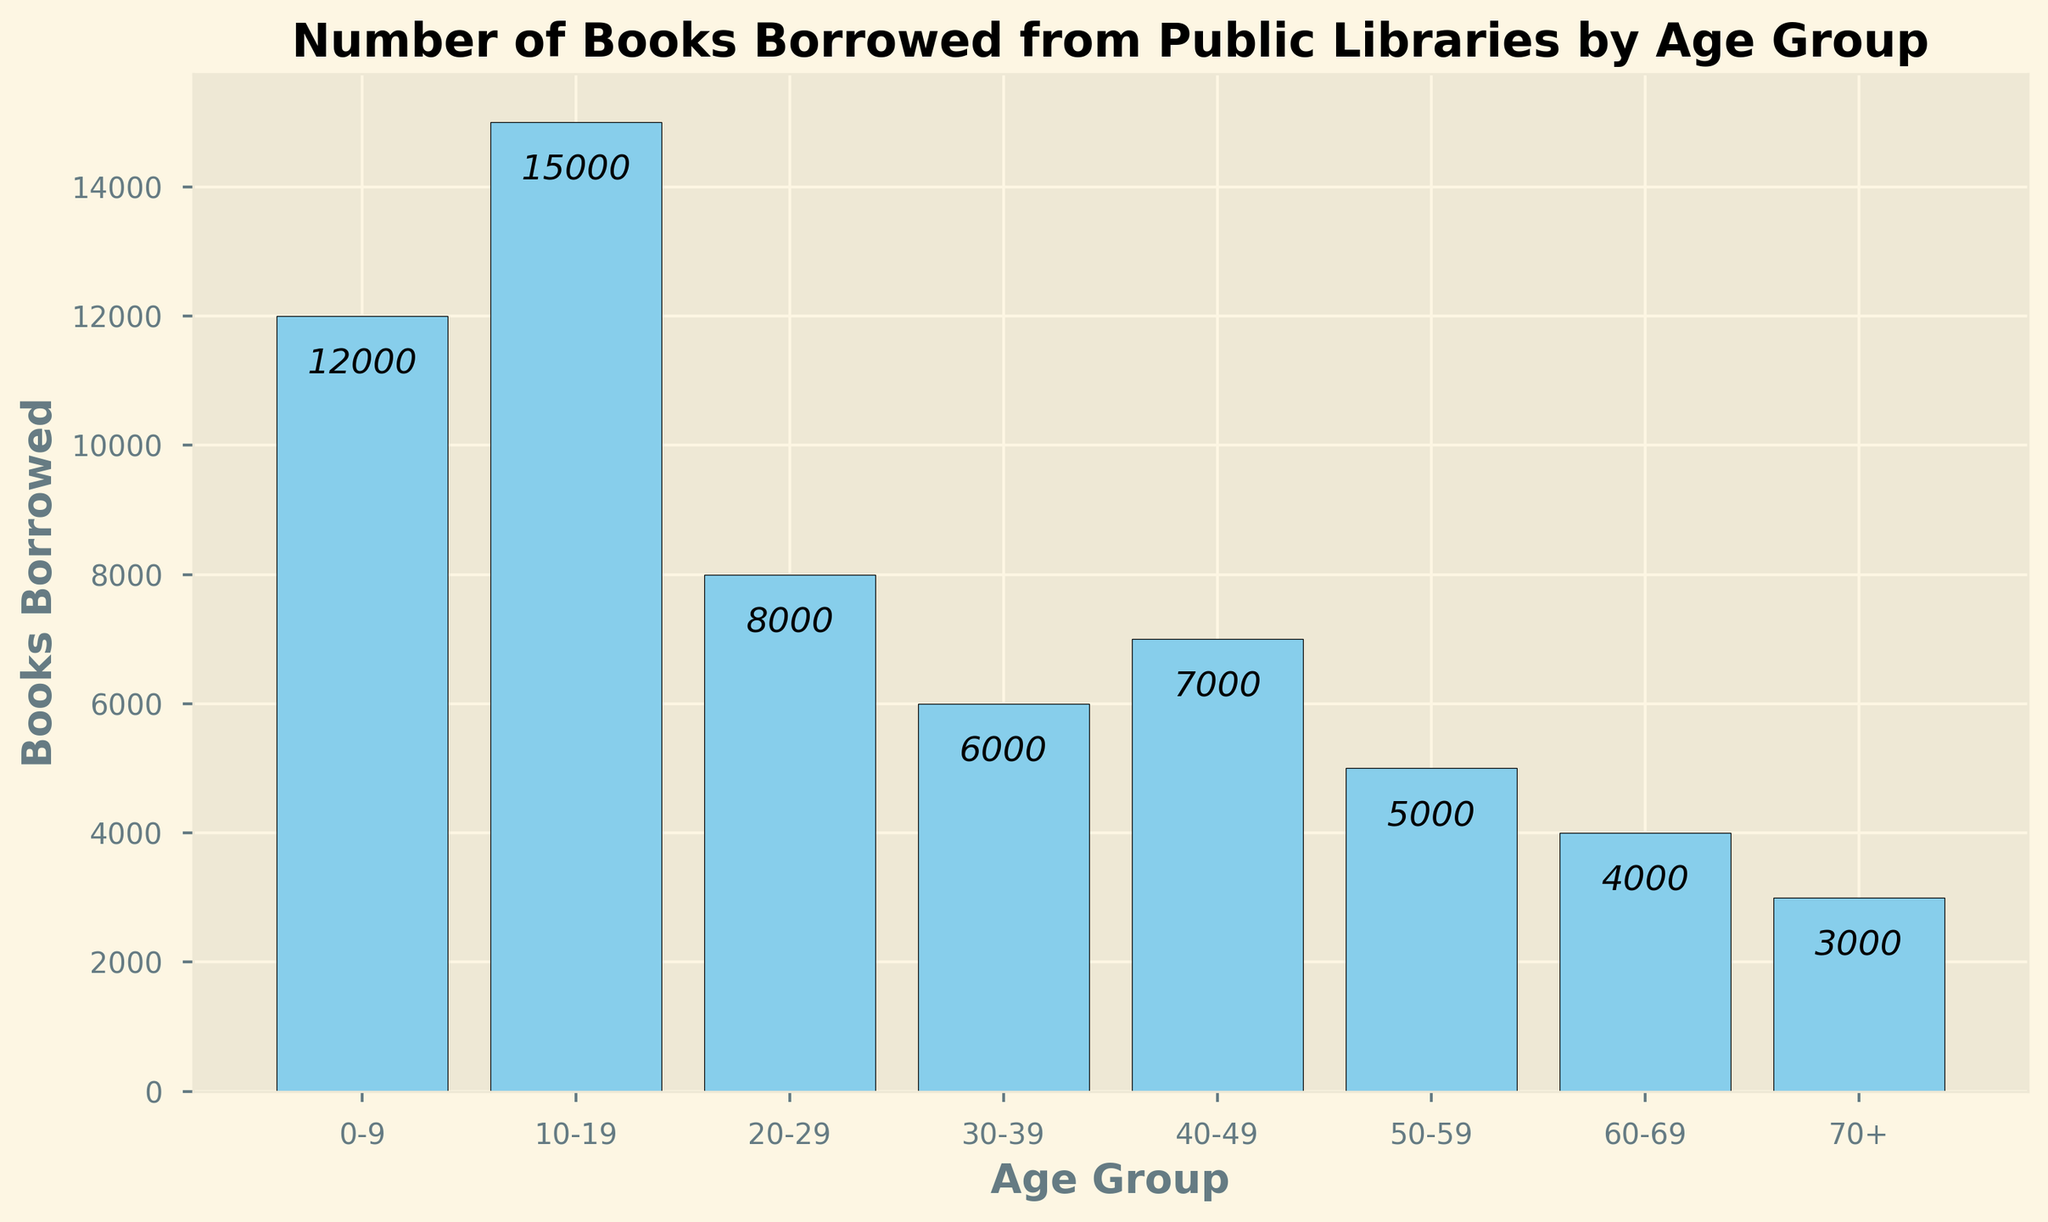Which age group borrowed the most books? By looking at the figure, the age group with the tallest bar represents the group that borrowed the most books. The bar for the 10-19 age group is the tallest.
Answer: 10-19 Which age group borrowed the least books? By looking at the figure, the age group with the shortest bar represents the group that borrowed the least books. The bar for the 70+ age group is the shortest.
Answer: 70+ How many more books were borrowed by the 10-19 age group compared to the 50-59 age group? Identify the number of books borrowed by each group from the bars: 10-19 age group borrowed 15,000 books, 50-59 age group borrowed 5,000 books. Subtract the smaller number from the larger: 15,000 - 5,000.
Answer: 10,000 What is the total number of books borrowed by the age groups 0-9 and 60-69 combined? Identify the number of books borrowed by each group from the bars: 0-9 age group borrowed 12,000 books, 60-69 age group borrowed 4,000 books. Add the two numbers: 12,000 + 4,000.
Answer: 16,000 Which age group borrowed more books, the 20-29 group or the 30-39 group? Compare the heights of the bars for the 20-29 and 30-39 age groups. The 20-29 group borrowed 8,000 books, while the 30-39 group borrowed 6,000 books. 8,000 is greater than 6,000.
Answer: 20-29 What is the average number of books borrowed across all age groups? Sum the total number of books borrowed by all age groups: 12,000 + 15,000 + 8,000 + 6,000 + 7,000 + 5,000 + 4,000 + 3,000 = 60,000. Divide by the number of age groups, which is 8. 60,000 / 8.
Answer: 7,500 How many books were borrowed by the combined age groups of 40-49 and 50-59? Identify the number of books borrowed by each group from the bars: 40-49 age group borrowed 7,000 books, 50-59 age group borrowed 5,000 books. Add the two numbers: 7,000 + 5,000.
Answer: 12,000 Which age group between 30 and 60 borrowed the fewest books? Identify the number of books borrowed by each age group within the 30-60 range: 30-39 group borrowed 6,000 books, 40-49 group borrowed 7,000 books, 50-59 group borrowed 5,000 books. The age group with the lowest bar is 50-59.
Answer: 50-59 Is the number of books borrowed by the 20-29 age group greater than the number borrowed by the 70+ age group? Compare the heights of the bars for the 20-29 and 70+ age groups. The 20-29 group borrowed 8,000 books, while the 70+ group borrowed 3,000 books. 8,000 is greater than 3,000.
Answer: Yes 